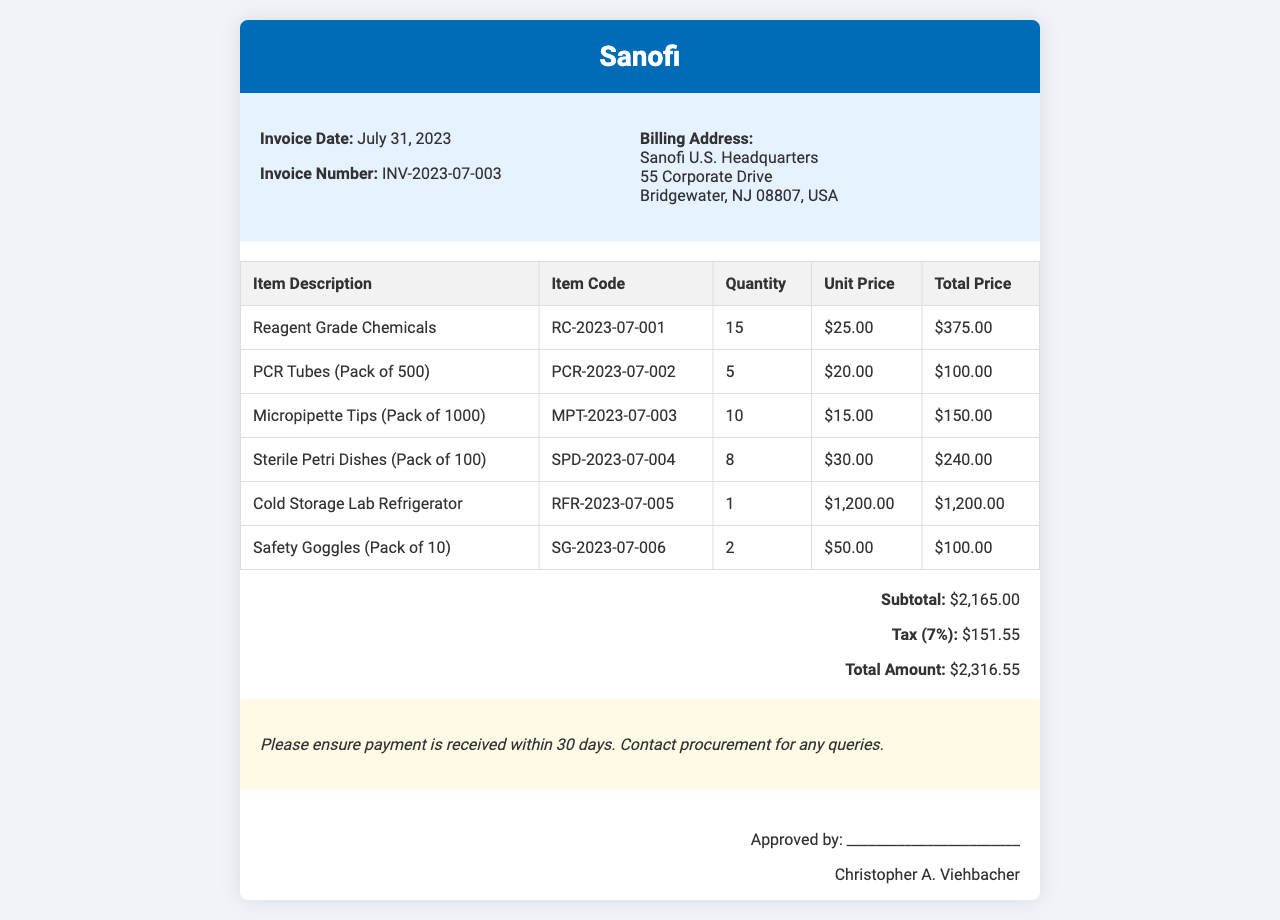What is the invoice date? The invoice date is explicitly mentioned in the document as July 31, 2023.
Answer: July 31, 2023 What is the invoice number? The invoice number can be found in the header section, listed as INV-2023-07-003.
Answer: INV-2023-07-003 What is the total amount due? The total amount is provided at the bottom of the invoice, calculated as $2,316.55.
Answer: $2,316.55 How many units of sterile petri dishes were ordered? The quantity of sterile petri dishes is listed in the table as 8.
Answer: 8 What is the unit price of micropipette tips? The unit price for micropipette tips is indicated in the table as $15.00.
Answer: $15.00 What is the subtotal before tax? The subtotal before tax is listed in the totals section as $2,165.00.
Answer: $2,165.00 How many items are listed in total on the invoice? There are 6 items listed in the invoice as outlined in the table.
Answer: 6 What is the tax percentage applied to the invoice? The tax percentage is indicated in the totals section as 7%.
Answer: 7% What was the item code for the cold storage lab refrigerator? The item code for the cold storage lab refrigerator is provided as RFR-2023-07-005.
Answer: RFR-2023-07-005 